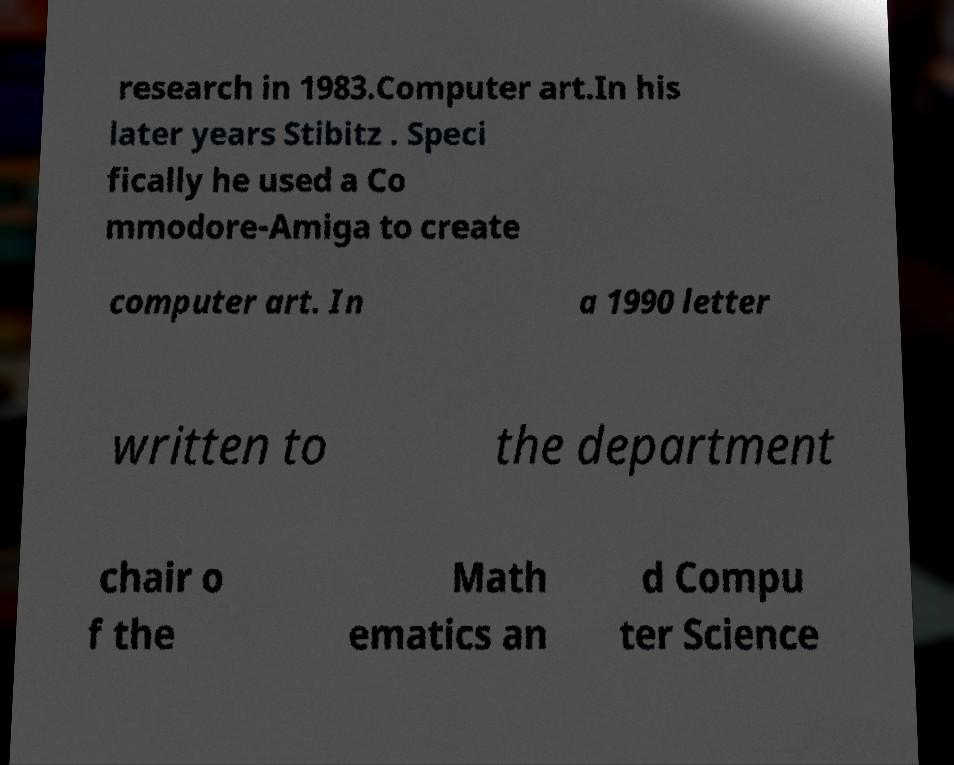For documentation purposes, I need the text within this image transcribed. Could you provide that? research in 1983.Computer art.In his later years Stibitz . Speci fically he used a Co mmodore-Amiga to create computer art. In a 1990 letter written to the department chair o f the Math ematics an d Compu ter Science 